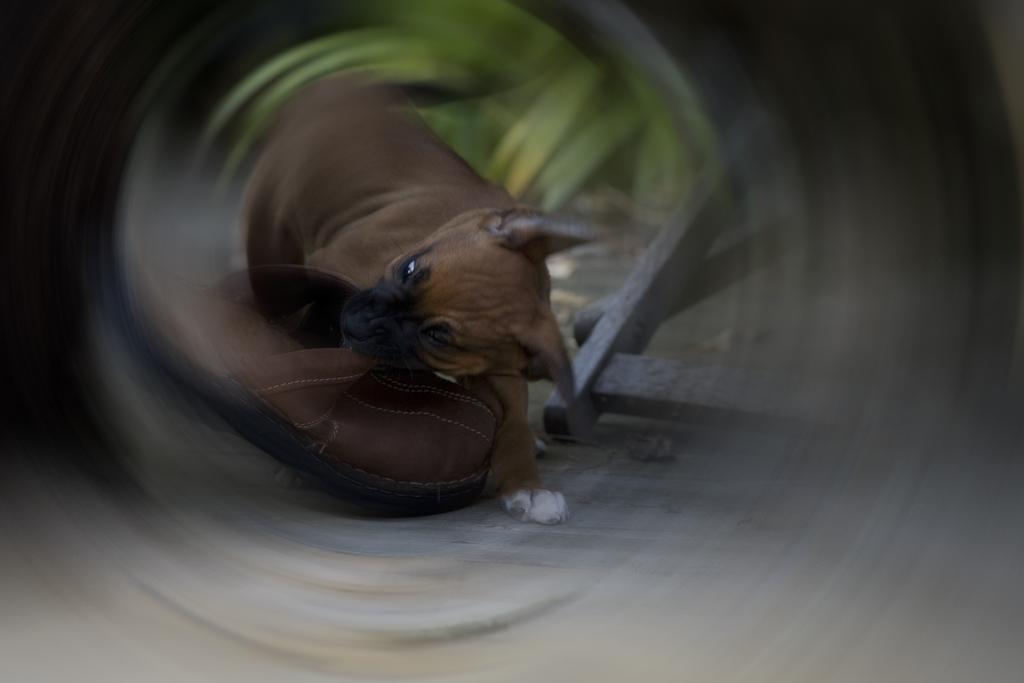Can you describe this image briefly? In this image we can see a dog and there is a shoe. In the background there is a stand. 